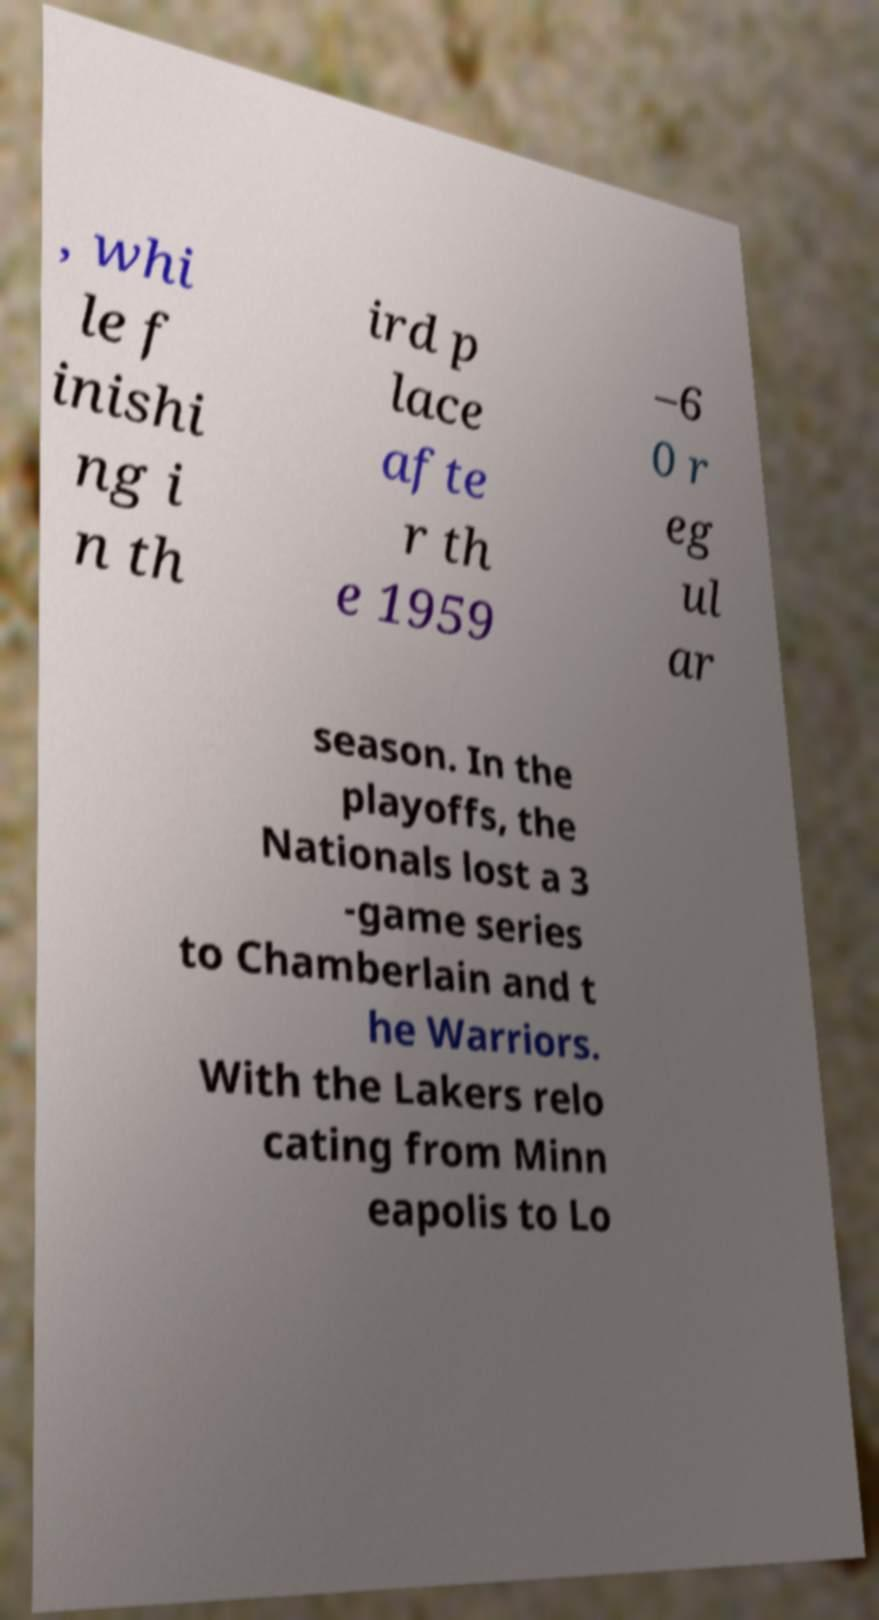What messages or text are displayed in this image? I need them in a readable, typed format. , whi le f inishi ng i n th ird p lace afte r th e 1959 –6 0 r eg ul ar season. In the playoffs, the Nationals lost a 3 -game series to Chamberlain and t he Warriors. With the Lakers relo cating from Minn eapolis to Lo 